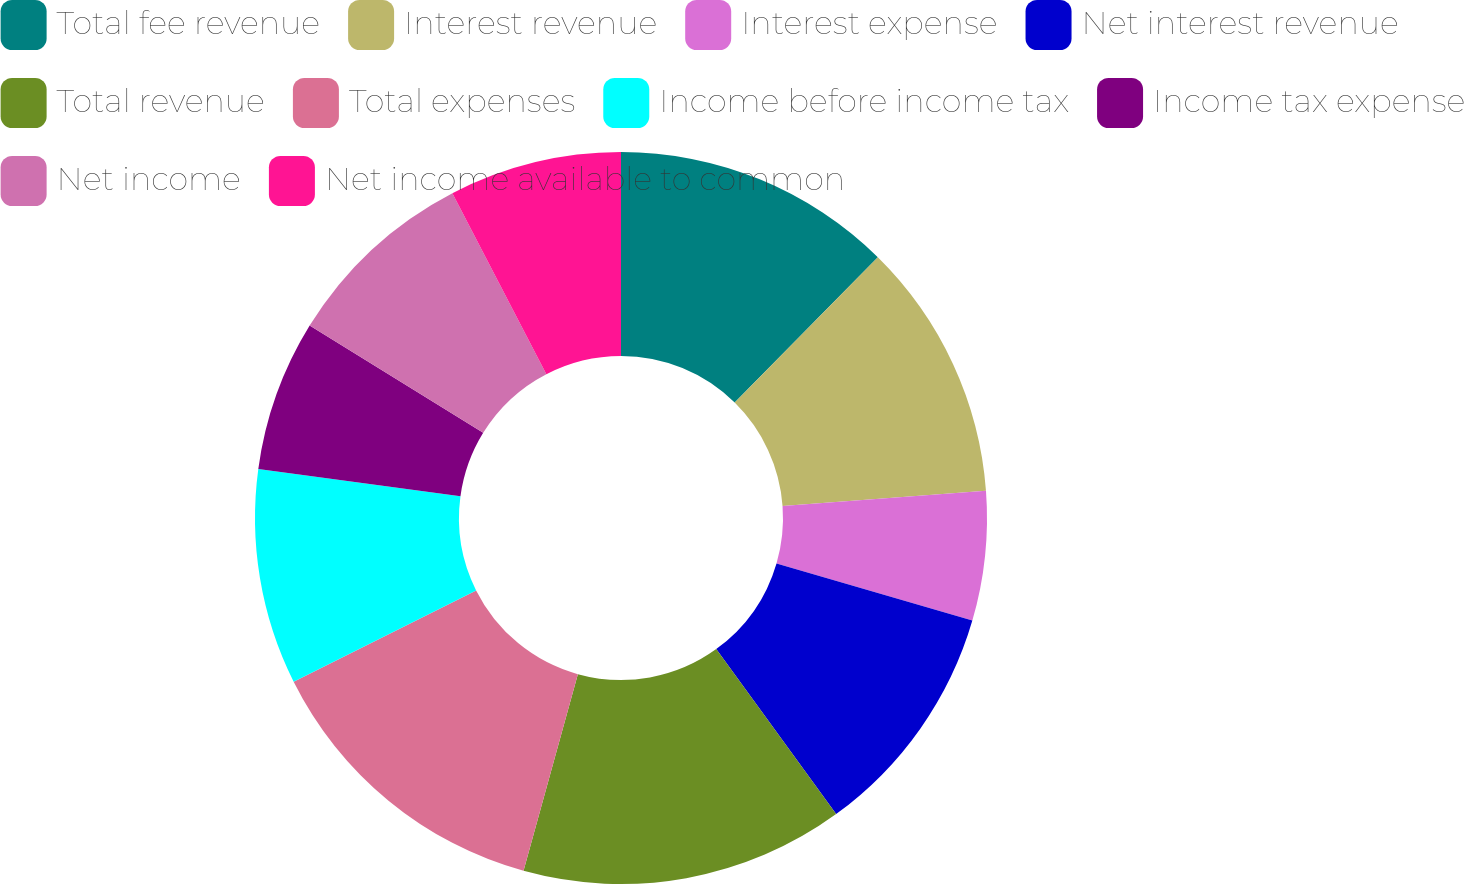<chart> <loc_0><loc_0><loc_500><loc_500><pie_chart><fcel>Total fee revenue<fcel>Interest revenue<fcel>Interest expense<fcel>Net interest revenue<fcel>Total revenue<fcel>Total expenses<fcel>Income before income tax<fcel>Income tax expense<fcel>Net income<fcel>Net income available to common<nl><fcel>12.38%<fcel>11.43%<fcel>5.71%<fcel>10.48%<fcel>14.29%<fcel>13.33%<fcel>9.52%<fcel>6.67%<fcel>8.57%<fcel>7.62%<nl></chart> 